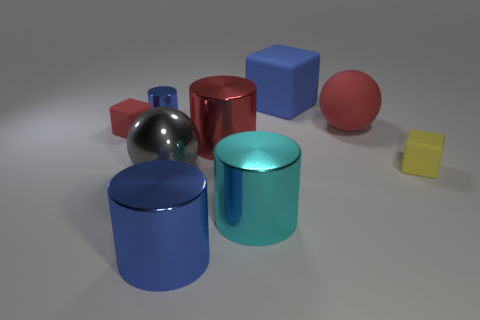Add 1 big rubber things. How many objects exist? 10 Subtract all tiny rubber blocks. How many blocks are left? 1 Subtract 1 blocks. How many blocks are left? 2 Subtract all blocks. How many objects are left? 6 Subtract all red cylinders. How many cylinders are left? 3 Subtract 0 purple cylinders. How many objects are left? 9 Subtract all purple balls. Subtract all green cylinders. How many balls are left? 2 Subtract all blue blocks. How many green cylinders are left? 0 Subtract all small yellow matte things. Subtract all big blue cylinders. How many objects are left? 7 Add 3 red rubber blocks. How many red rubber blocks are left? 4 